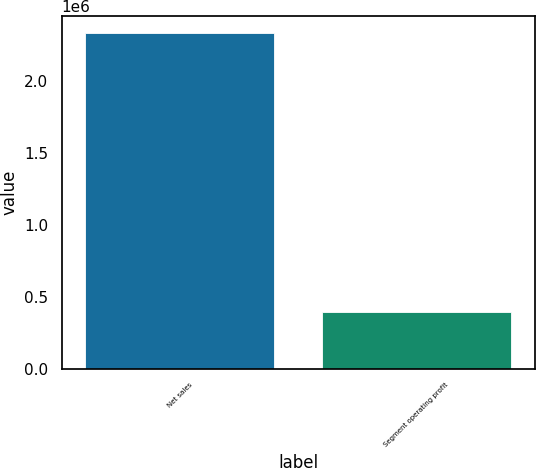<chart> <loc_0><loc_0><loc_500><loc_500><bar_chart><fcel>Net sales<fcel>Segment operating profit<nl><fcel>2.33401e+06<fcel>396763<nl></chart> 